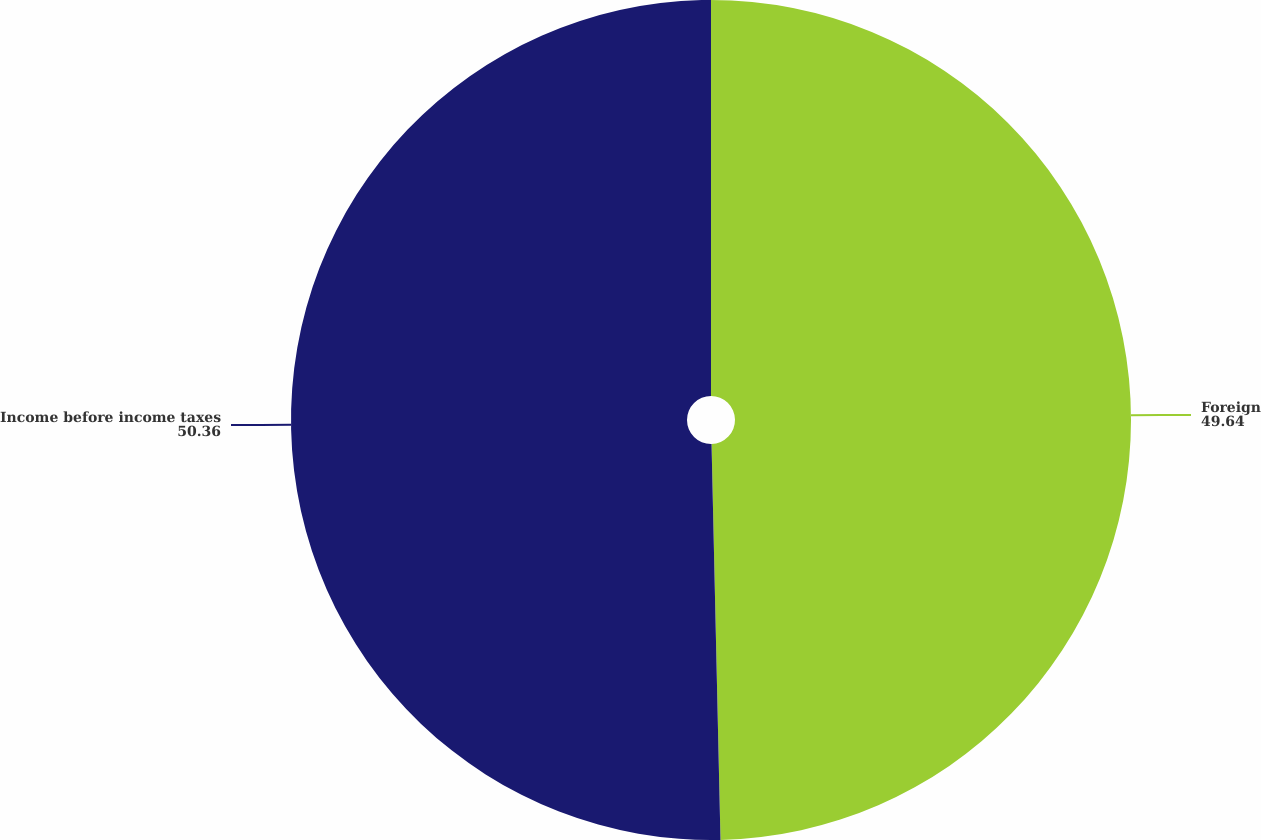Convert chart to OTSL. <chart><loc_0><loc_0><loc_500><loc_500><pie_chart><fcel>Foreign<fcel>Income before income taxes<nl><fcel>49.64%<fcel>50.36%<nl></chart> 